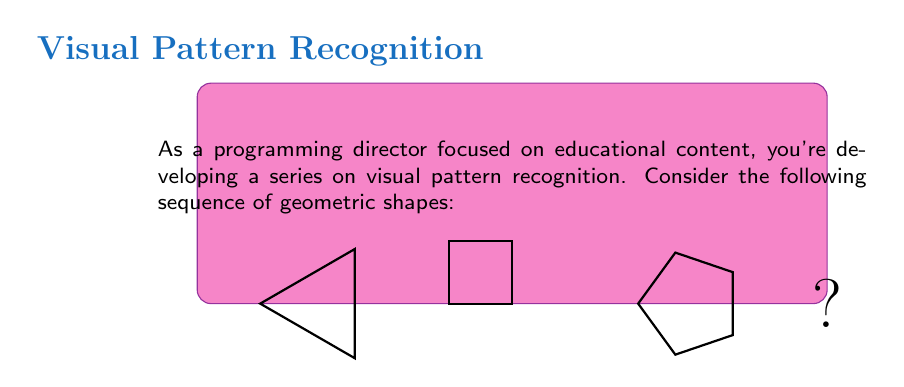Teach me how to tackle this problem. To identify the missing pattern in this sequence of geometric shapes, let's analyze the progression:

1. The first shape is a triangle (3 sides).
2. The second shape is a square (4 sides).
3. The third shape is a pentagon (5 sides).

We can observe that the number of sides is increasing by 1 in each step:

$$3 \rightarrow 4 \rightarrow 5 \rightarrow ?$$

To find the next number in this arithmetic sequence, we add 1 to the previous number:

$$5 + 1 = 6$$

Therefore, the next shape in the sequence should have 6 sides, which is a hexagon.

This pattern aligns with the programming director's goal of creating educational content, as it teaches viewers about geometric progression and shape recognition.
Answer: Hexagon 